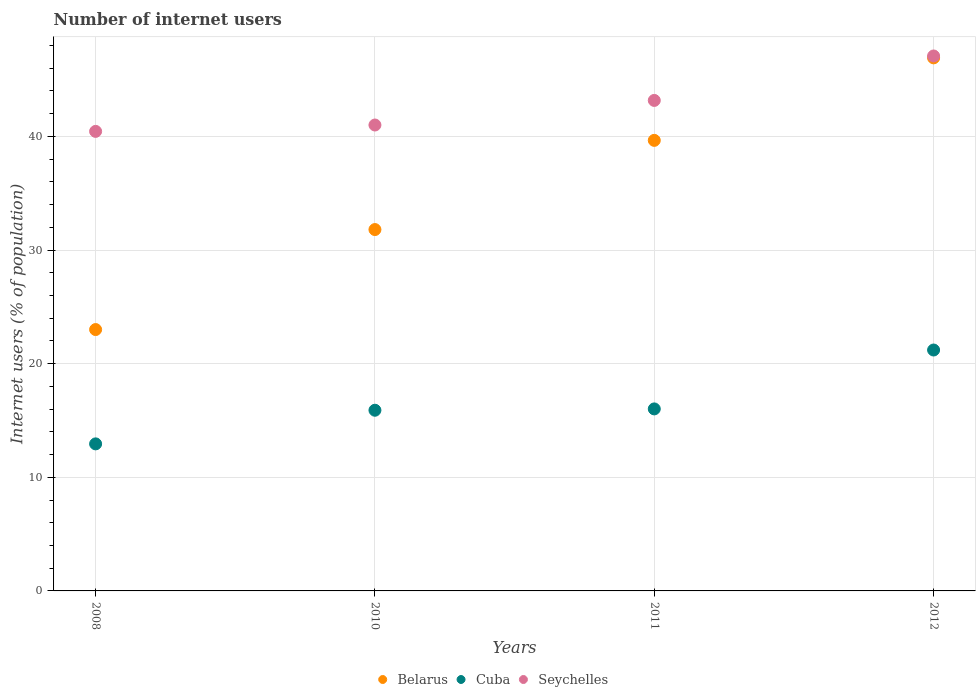Is the number of dotlines equal to the number of legend labels?
Your answer should be compact. Yes. What is the number of internet users in Belarus in 2012?
Your answer should be very brief. 46.91. Across all years, what is the maximum number of internet users in Seychelles?
Provide a short and direct response. 47.08. Across all years, what is the minimum number of internet users in Seychelles?
Make the answer very short. 40.44. In which year was the number of internet users in Cuba maximum?
Provide a short and direct response. 2012. What is the total number of internet users in Cuba in the graph?
Offer a very short reply. 66.06. What is the difference between the number of internet users in Belarus in 2008 and that in 2011?
Provide a succinct answer. -16.65. What is the difference between the number of internet users in Seychelles in 2011 and the number of internet users in Belarus in 2008?
Ensure brevity in your answer.  20.16. What is the average number of internet users in Seychelles per year?
Offer a terse response. 42.92. In the year 2010, what is the difference between the number of internet users in Belarus and number of internet users in Cuba?
Make the answer very short. 15.9. In how many years, is the number of internet users in Cuba greater than 24 %?
Offer a terse response. 0. What is the ratio of the number of internet users in Cuba in 2010 to that in 2012?
Offer a very short reply. 0.75. What is the difference between the highest and the second highest number of internet users in Cuba?
Keep it short and to the point. 5.18. What is the difference between the highest and the lowest number of internet users in Cuba?
Provide a succinct answer. 8.26. In how many years, is the number of internet users in Cuba greater than the average number of internet users in Cuba taken over all years?
Give a very brief answer. 1. Is the sum of the number of internet users in Seychelles in 2008 and 2011 greater than the maximum number of internet users in Cuba across all years?
Provide a succinct answer. Yes. Does the number of internet users in Seychelles monotonically increase over the years?
Your response must be concise. Yes. Is the number of internet users in Seychelles strictly less than the number of internet users in Belarus over the years?
Offer a terse response. No. How many dotlines are there?
Offer a terse response. 3. Does the graph contain grids?
Give a very brief answer. Yes. Where does the legend appear in the graph?
Your answer should be compact. Bottom center. How are the legend labels stacked?
Provide a short and direct response. Horizontal. What is the title of the graph?
Ensure brevity in your answer.  Number of internet users. What is the label or title of the Y-axis?
Keep it short and to the point. Internet users (% of population). What is the Internet users (% of population) of Belarus in 2008?
Your answer should be very brief. 23. What is the Internet users (% of population) of Cuba in 2008?
Keep it short and to the point. 12.94. What is the Internet users (% of population) of Seychelles in 2008?
Your response must be concise. 40.44. What is the Internet users (% of population) of Belarus in 2010?
Your answer should be very brief. 31.8. What is the Internet users (% of population) of Seychelles in 2010?
Your answer should be compact. 41. What is the Internet users (% of population) of Belarus in 2011?
Ensure brevity in your answer.  39.65. What is the Internet users (% of population) of Cuba in 2011?
Make the answer very short. 16.02. What is the Internet users (% of population) of Seychelles in 2011?
Give a very brief answer. 43.16. What is the Internet users (% of population) in Belarus in 2012?
Ensure brevity in your answer.  46.91. What is the Internet users (% of population) of Cuba in 2012?
Make the answer very short. 21.2. What is the Internet users (% of population) of Seychelles in 2012?
Provide a succinct answer. 47.08. Across all years, what is the maximum Internet users (% of population) of Belarus?
Your response must be concise. 46.91. Across all years, what is the maximum Internet users (% of population) in Cuba?
Offer a very short reply. 21.2. Across all years, what is the maximum Internet users (% of population) of Seychelles?
Make the answer very short. 47.08. Across all years, what is the minimum Internet users (% of population) of Cuba?
Your answer should be compact. 12.94. Across all years, what is the minimum Internet users (% of population) of Seychelles?
Provide a succinct answer. 40.44. What is the total Internet users (% of population) of Belarus in the graph?
Offer a terse response. 141.36. What is the total Internet users (% of population) of Cuba in the graph?
Offer a very short reply. 66.06. What is the total Internet users (% of population) of Seychelles in the graph?
Offer a terse response. 171.68. What is the difference between the Internet users (% of population) in Belarus in 2008 and that in 2010?
Offer a terse response. -8.8. What is the difference between the Internet users (% of population) in Cuba in 2008 and that in 2010?
Provide a short and direct response. -2.96. What is the difference between the Internet users (% of population) of Seychelles in 2008 and that in 2010?
Your answer should be very brief. -0.56. What is the difference between the Internet users (% of population) in Belarus in 2008 and that in 2011?
Ensure brevity in your answer.  -16.65. What is the difference between the Internet users (% of population) in Cuba in 2008 and that in 2011?
Offer a terse response. -3.08. What is the difference between the Internet users (% of population) in Seychelles in 2008 and that in 2011?
Ensure brevity in your answer.  -2.72. What is the difference between the Internet users (% of population) of Belarus in 2008 and that in 2012?
Offer a very short reply. -23.91. What is the difference between the Internet users (% of population) of Cuba in 2008 and that in 2012?
Keep it short and to the point. -8.26. What is the difference between the Internet users (% of population) of Seychelles in 2008 and that in 2012?
Provide a succinct answer. -6.64. What is the difference between the Internet users (% of population) of Belarus in 2010 and that in 2011?
Make the answer very short. -7.85. What is the difference between the Internet users (% of population) of Cuba in 2010 and that in 2011?
Ensure brevity in your answer.  -0.12. What is the difference between the Internet users (% of population) in Seychelles in 2010 and that in 2011?
Provide a short and direct response. -2.16. What is the difference between the Internet users (% of population) of Belarus in 2010 and that in 2012?
Ensure brevity in your answer.  -15.11. What is the difference between the Internet users (% of population) of Cuba in 2010 and that in 2012?
Ensure brevity in your answer.  -5.3. What is the difference between the Internet users (% of population) of Seychelles in 2010 and that in 2012?
Make the answer very short. -6.08. What is the difference between the Internet users (% of population) of Belarus in 2011 and that in 2012?
Your answer should be compact. -7.26. What is the difference between the Internet users (% of population) in Cuba in 2011 and that in 2012?
Make the answer very short. -5.18. What is the difference between the Internet users (% of population) in Seychelles in 2011 and that in 2012?
Your answer should be compact. -3.91. What is the difference between the Internet users (% of population) in Belarus in 2008 and the Internet users (% of population) in Seychelles in 2010?
Your answer should be very brief. -18. What is the difference between the Internet users (% of population) of Cuba in 2008 and the Internet users (% of population) of Seychelles in 2010?
Provide a succinct answer. -28.06. What is the difference between the Internet users (% of population) of Belarus in 2008 and the Internet users (% of population) of Cuba in 2011?
Give a very brief answer. 6.98. What is the difference between the Internet users (% of population) in Belarus in 2008 and the Internet users (% of population) in Seychelles in 2011?
Provide a succinct answer. -20.16. What is the difference between the Internet users (% of population) in Cuba in 2008 and the Internet users (% of population) in Seychelles in 2011?
Make the answer very short. -30.22. What is the difference between the Internet users (% of population) in Belarus in 2008 and the Internet users (% of population) in Cuba in 2012?
Give a very brief answer. 1.8. What is the difference between the Internet users (% of population) of Belarus in 2008 and the Internet users (% of population) of Seychelles in 2012?
Keep it short and to the point. -24.08. What is the difference between the Internet users (% of population) of Cuba in 2008 and the Internet users (% of population) of Seychelles in 2012?
Give a very brief answer. -34.14. What is the difference between the Internet users (% of population) of Belarus in 2010 and the Internet users (% of population) of Cuba in 2011?
Give a very brief answer. 15.78. What is the difference between the Internet users (% of population) in Belarus in 2010 and the Internet users (% of population) in Seychelles in 2011?
Provide a short and direct response. -11.36. What is the difference between the Internet users (% of population) in Cuba in 2010 and the Internet users (% of population) in Seychelles in 2011?
Offer a terse response. -27.26. What is the difference between the Internet users (% of population) in Belarus in 2010 and the Internet users (% of population) in Cuba in 2012?
Your answer should be very brief. 10.6. What is the difference between the Internet users (% of population) in Belarus in 2010 and the Internet users (% of population) in Seychelles in 2012?
Provide a short and direct response. -15.28. What is the difference between the Internet users (% of population) of Cuba in 2010 and the Internet users (% of population) of Seychelles in 2012?
Give a very brief answer. -31.18. What is the difference between the Internet users (% of population) in Belarus in 2011 and the Internet users (% of population) in Cuba in 2012?
Provide a short and direct response. 18.45. What is the difference between the Internet users (% of population) in Belarus in 2011 and the Internet users (% of population) in Seychelles in 2012?
Your answer should be very brief. -7.43. What is the difference between the Internet users (% of population) of Cuba in 2011 and the Internet users (% of population) of Seychelles in 2012?
Your response must be concise. -31.06. What is the average Internet users (% of population) of Belarus per year?
Make the answer very short. 35.34. What is the average Internet users (% of population) of Cuba per year?
Offer a terse response. 16.51. What is the average Internet users (% of population) of Seychelles per year?
Give a very brief answer. 42.92. In the year 2008, what is the difference between the Internet users (% of population) of Belarus and Internet users (% of population) of Cuba?
Offer a very short reply. 10.06. In the year 2008, what is the difference between the Internet users (% of population) in Belarus and Internet users (% of population) in Seychelles?
Ensure brevity in your answer.  -17.44. In the year 2008, what is the difference between the Internet users (% of population) in Cuba and Internet users (% of population) in Seychelles?
Give a very brief answer. -27.5. In the year 2010, what is the difference between the Internet users (% of population) of Belarus and Internet users (% of population) of Seychelles?
Keep it short and to the point. -9.2. In the year 2010, what is the difference between the Internet users (% of population) of Cuba and Internet users (% of population) of Seychelles?
Offer a terse response. -25.1. In the year 2011, what is the difference between the Internet users (% of population) of Belarus and Internet users (% of population) of Cuba?
Ensure brevity in your answer.  23.63. In the year 2011, what is the difference between the Internet users (% of population) in Belarus and Internet users (% of population) in Seychelles?
Offer a terse response. -3.52. In the year 2011, what is the difference between the Internet users (% of population) in Cuba and Internet users (% of population) in Seychelles?
Offer a very short reply. -27.15. In the year 2012, what is the difference between the Internet users (% of population) of Belarus and Internet users (% of population) of Cuba?
Provide a succinct answer. 25.71. In the year 2012, what is the difference between the Internet users (% of population) in Belarus and Internet users (% of population) in Seychelles?
Offer a very short reply. -0.17. In the year 2012, what is the difference between the Internet users (% of population) in Cuba and Internet users (% of population) in Seychelles?
Give a very brief answer. -25.88. What is the ratio of the Internet users (% of population) in Belarus in 2008 to that in 2010?
Your response must be concise. 0.72. What is the ratio of the Internet users (% of population) of Cuba in 2008 to that in 2010?
Provide a succinct answer. 0.81. What is the ratio of the Internet users (% of population) of Seychelles in 2008 to that in 2010?
Keep it short and to the point. 0.99. What is the ratio of the Internet users (% of population) in Belarus in 2008 to that in 2011?
Offer a very short reply. 0.58. What is the ratio of the Internet users (% of population) in Cuba in 2008 to that in 2011?
Give a very brief answer. 0.81. What is the ratio of the Internet users (% of population) of Seychelles in 2008 to that in 2011?
Keep it short and to the point. 0.94. What is the ratio of the Internet users (% of population) of Belarus in 2008 to that in 2012?
Make the answer very short. 0.49. What is the ratio of the Internet users (% of population) of Cuba in 2008 to that in 2012?
Your response must be concise. 0.61. What is the ratio of the Internet users (% of population) in Seychelles in 2008 to that in 2012?
Keep it short and to the point. 0.86. What is the ratio of the Internet users (% of population) of Belarus in 2010 to that in 2011?
Offer a terse response. 0.8. What is the ratio of the Internet users (% of population) of Seychelles in 2010 to that in 2011?
Keep it short and to the point. 0.95. What is the ratio of the Internet users (% of population) of Belarus in 2010 to that in 2012?
Provide a short and direct response. 0.68. What is the ratio of the Internet users (% of population) in Cuba in 2010 to that in 2012?
Your answer should be very brief. 0.75. What is the ratio of the Internet users (% of population) of Seychelles in 2010 to that in 2012?
Provide a succinct answer. 0.87. What is the ratio of the Internet users (% of population) in Belarus in 2011 to that in 2012?
Your response must be concise. 0.85. What is the ratio of the Internet users (% of population) in Cuba in 2011 to that in 2012?
Make the answer very short. 0.76. What is the ratio of the Internet users (% of population) of Seychelles in 2011 to that in 2012?
Give a very brief answer. 0.92. What is the difference between the highest and the second highest Internet users (% of population) in Belarus?
Provide a succinct answer. 7.26. What is the difference between the highest and the second highest Internet users (% of population) in Cuba?
Give a very brief answer. 5.18. What is the difference between the highest and the second highest Internet users (% of population) in Seychelles?
Keep it short and to the point. 3.91. What is the difference between the highest and the lowest Internet users (% of population) in Belarus?
Make the answer very short. 23.91. What is the difference between the highest and the lowest Internet users (% of population) in Cuba?
Give a very brief answer. 8.26. What is the difference between the highest and the lowest Internet users (% of population) of Seychelles?
Ensure brevity in your answer.  6.64. 